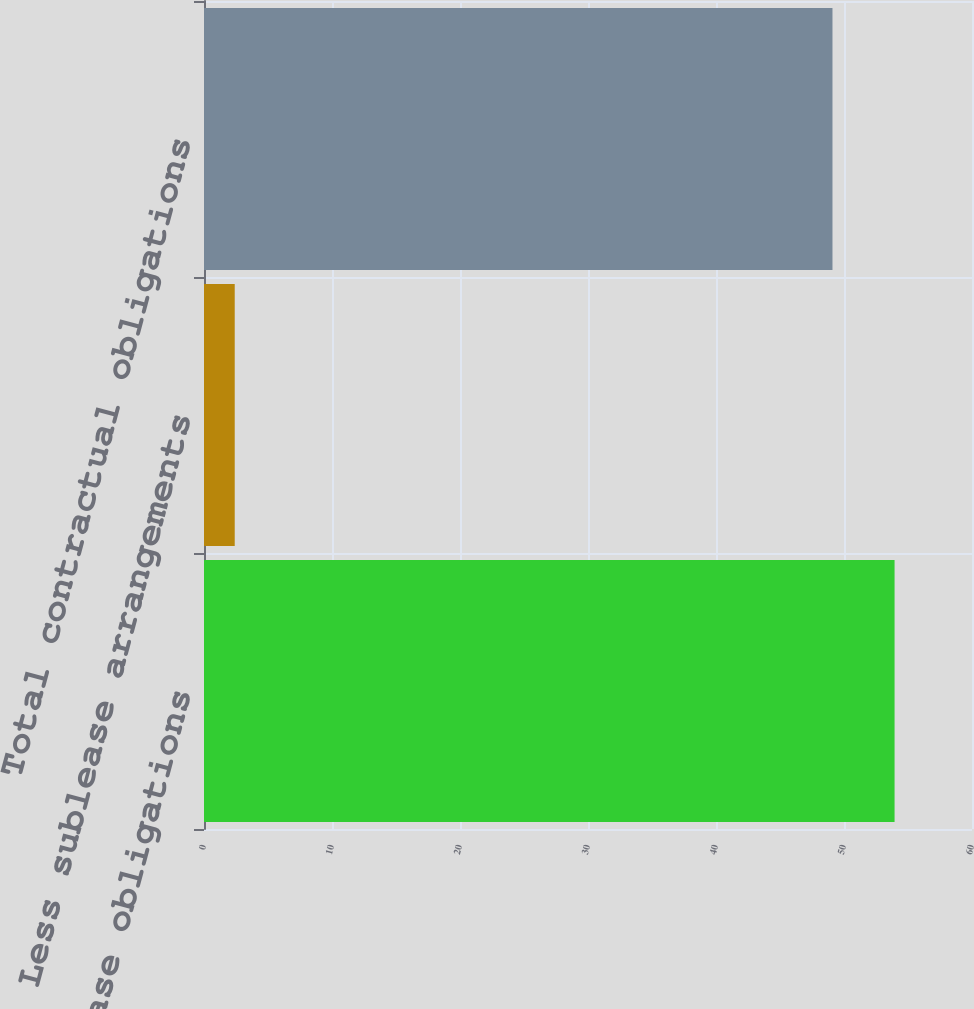Convert chart to OTSL. <chart><loc_0><loc_0><loc_500><loc_500><bar_chart><fcel>Operating lease obligations<fcel>Less sublease arrangements<fcel>Total contractual obligations<nl><fcel>53.95<fcel>2.4<fcel>49.1<nl></chart> 